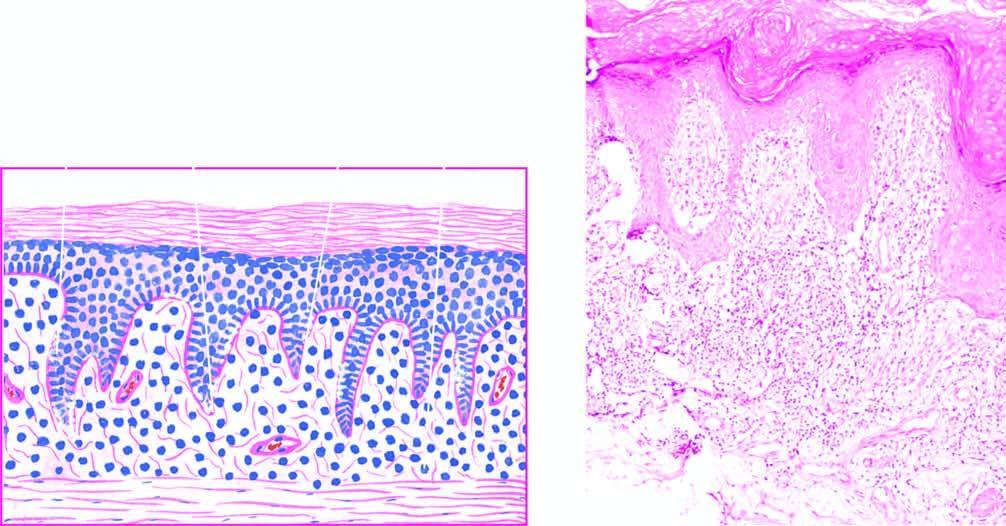s there hyperkeratosis, focal hypergranulosis and irregular acanthosis with elongated saw-toothed rete ridges?
Answer the question using a single word or phrase. Yes 